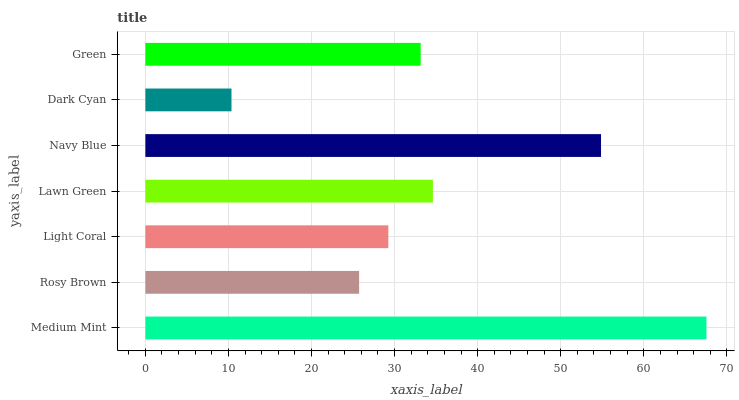Is Dark Cyan the minimum?
Answer yes or no. Yes. Is Medium Mint the maximum?
Answer yes or no. Yes. Is Rosy Brown the minimum?
Answer yes or no. No. Is Rosy Brown the maximum?
Answer yes or no. No. Is Medium Mint greater than Rosy Brown?
Answer yes or no. Yes. Is Rosy Brown less than Medium Mint?
Answer yes or no. Yes. Is Rosy Brown greater than Medium Mint?
Answer yes or no. No. Is Medium Mint less than Rosy Brown?
Answer yes or no. No. Is Green the high median?
Answer yes or no. Yes. Is Green the low median?
Answer yes or no. Yes. Is Medium Mint the high median?
Answer yes or no. No. Is Navy Blue the low median?
Answer yes or no. No. 